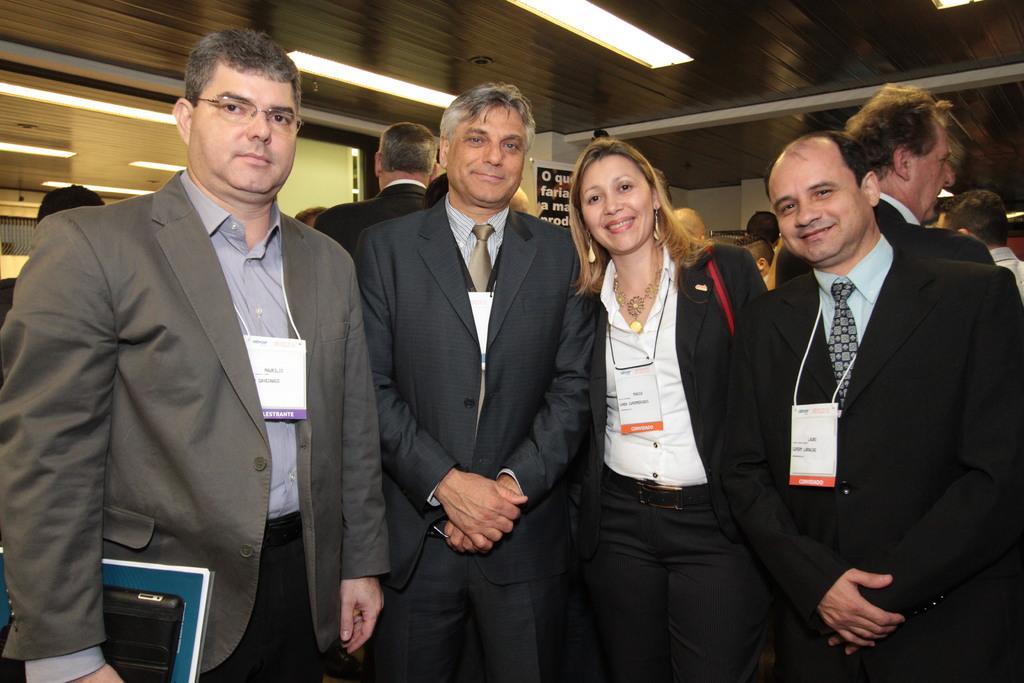Please provide a concise description of this image. There are persons in suits, smiling and standing. In the background, there are other persons and there are lights attached to the roof. 